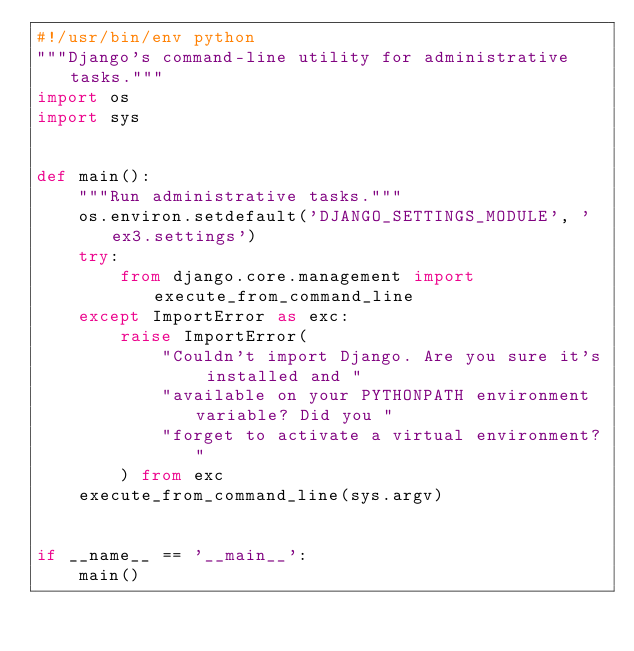Convert code to text. <code><loc_0><loc_0><loc_500><loc_500><_Python_>#!/usr/bin/env python
"""Django's command-line utility for administrative tasks."""
import os
import sys


def main():
    """Run administrative tasks."""
    os.environ.setdefault('DJANGO_SETTINGS_MODULE', 'ex3.settings')
    try:
        from django.core.management import execute_from_command_line
    except ImportError as exc:
        raise ImportError(
            "Couldn't import Django. Are you sure it's installed and "
            "available on your PYTHONPATH environment variable? Did you "
            "forget to activate a virtual environment?"
        ) from exc
    execute_from_command_line(sys.argv)


if __name__ == '__main__':
    main()
</code> 